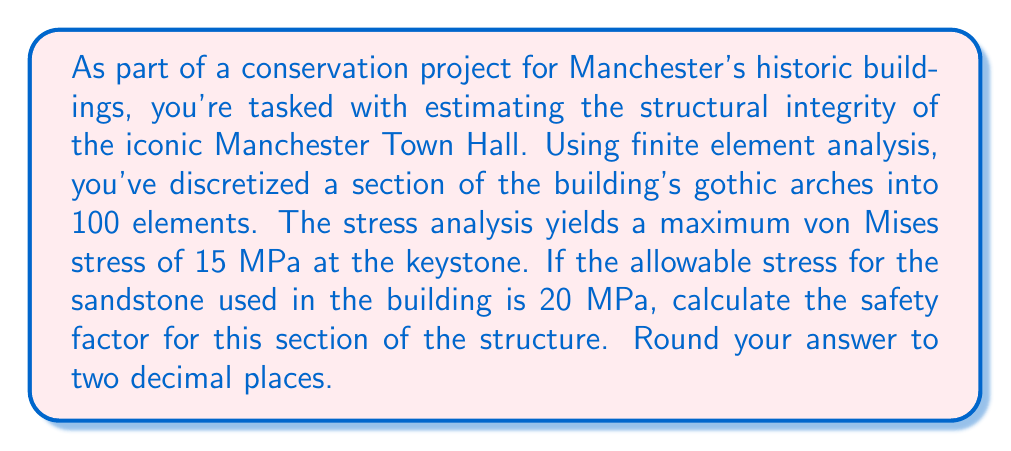Give your solution to this math problem. To solve this problem, we need to understand the concept of safety factor in structural engineering and how it relates to the stresses in the building.

1. Safety Factor Definition:
   The safety factor is a measure of how much stronger a system is than it needs to be for an intended load. It's calculated as:

   $$ \text{Safety Factor} = \frac{\text{Allowable Stress}}{\text{Maximum Applied Stress}} $$

2. Given Information:
   - Allowable stress for sandstone: $\sigma_{\text{allowable}} = 20 \text{ MPa}$
   - Maximum von Mises stress from analysis: $\sigma_{\text{max}} = 15 \text{ MPa}$

3. Calculation:
   Substituting these values into our safety factor equation:

   $$ \text{Safety Factor} = \frac{20 \text{ MPa}}{15 \text{ MPa}} = 1.3333... $$

4. Rounding:
   The question asks for the answer rounded to two decimal places.

   $$ 1.3333... \approx 1.33 $$

This safety factor indicates that the structure can withstand about 1.33 times the current stress before reaching the allowable stress limit, suggesting a reasonable margin of safety for this historic structure.
Answer: 1.33 